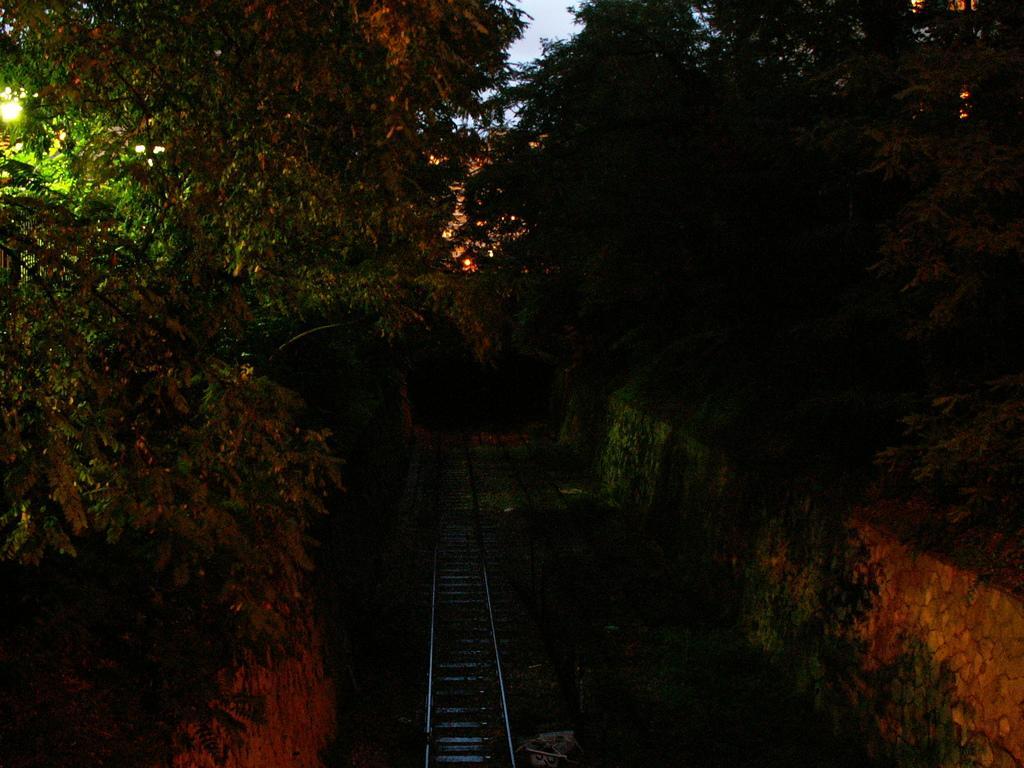Could you give a brief overview of what you see in this image? In this image there are trees and we can see walls. At the bottom there is a railway track. In the background there is sky. we can see lights. 